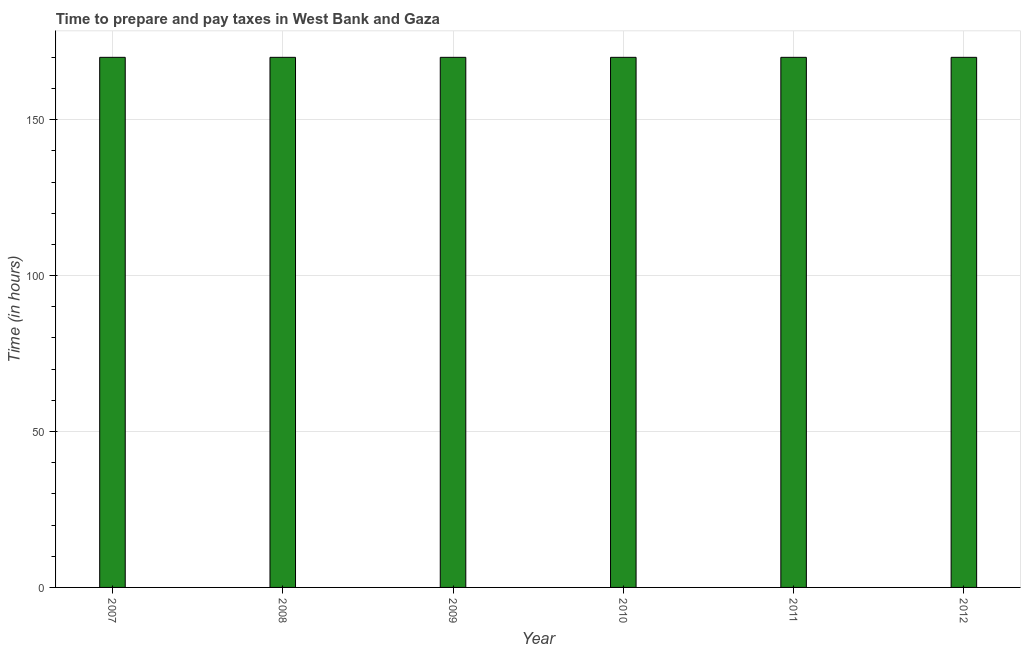What is the title of the graph?
Offer a terse response. Time to prepare and pay taxes in West Bank and Gaza. What is the label or title of the Y-axis?
Your answer should be very brief. Time (in hours). What is the time to prepare and pay taxes in 2011?
Provide a succinct answer. 170. Across all years, what is the maximum time to prepare and pay taxes?
Provide a succinct answer. 170. Across all years, what is the minimum time to prepare and pay taxes?
Offer a terse response. 170. What is the sum of the time to prepare and pay taxes?
Make the answer very short. 1020. What is the difference between the time to prepare and pay taxes in 2009 and 2012?
Provide a succinct answer. 0. What is the average time to prepare and pay taxes per year?
Your answer should be very brief. 170. What is the median time to prepare and pay taxes?
Offer a very short reply. 170. In how many years, is the time to prepare and pay taxes greater than 50 hours?
Provide a succinct answer. 6. Is the difference between the time to prepare and pay taxes in 2009 and 2010 greater than the difference between any two years?
Ensure brevity in your answer.  Yes. How many bars are there?
Your answer should be very brief. 6. Are all the bars in the graph horizontal?
Keep it short and to the point. No. How many years are there in the graph?
Your response must be concise. 6. What is the difference between two consecutive major ticks on the Y-axis?
Make the answer very short. 50. What is the Time (in hours) of 2007?
Offer a terse response. 170. What is the Time (in hours) in 2008?
Provide a succinct answer. 170. What is the Time (in hours) of 2009?
Give a very brief answer. 170. What is the Time (in hours) in 2010?
Provide a short and direct response. 170. What is the Time (in hours) of 2011?
Ensure brevity in your answer.  170. What is the Time (in hours) of 2012?
Ensure brevity in your answer.  170. What is the difference between the Time (in hours) in 2007 and 2008?
Your response must be concise. 0. What is the difference between the Time (in hours) in 2007 and 2012?
Your answer should be very brief. 0. What is the difference between the Time (in hours) in 2008 and 2009?
Ensure brevity in your answer.  0. What is the difference between the Time (in hours) in 2008 and 2012?
Your answer should be compact. 0. What is the difference between the Time (in hours) in 2009 and 2010?
Give a very brief answer. 0. What is the difference between the Time (in hours) in 2010 and 2012?
Offer a very short reply. 0. What is the difference between the Time (in hours) in 2011 and 2012?
Your answer should be very brief. 0. What is the ratio of the Time (in hours) in 2007 to that in 2009?
Provide a short and direct response. 1. What is the ratio of the Time (in hours) in 2007 to that in 2011?
Keep it short and to the point. 1. What is the ratio of the Time (in hours) in 2007 to that in 2012?
Provide a short and direct response. 1. What is the ratio of the Time (in hours) in 2008 to that in 2010?
Keep it short and to the point. 1. What is the ratio of the Time (in hours) in 2008 to that in 2011?
Your answer should be very brief. 1. What is the ratio of the Time (in hours) in 2009 to that in 2010?
Offer a terse response. 1. What is the ratio of the Time (in hours) in 2009 to that in 2011?
Keep it short and to the point. 1. 